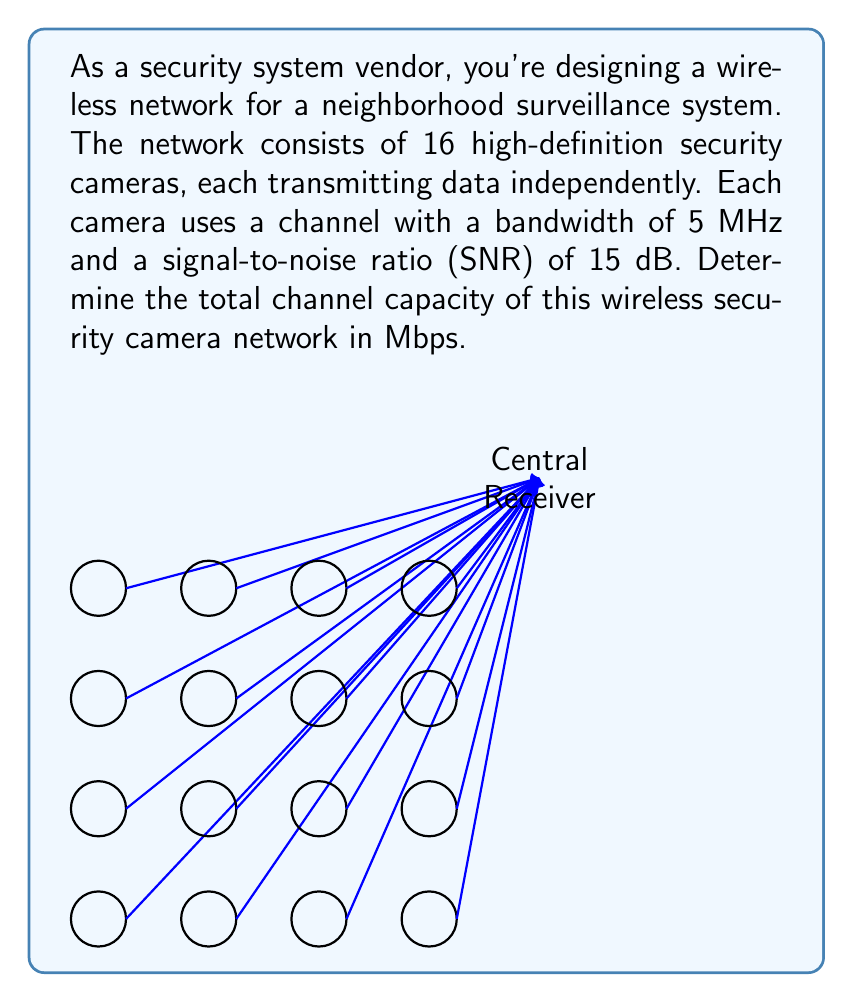Could you help me with this problem? Let's approach this step-by-step:

1) First, we need to calculate the channel capacity for a single camera using the Shannon-Hartley theorem:

   $C = B \log_2(1 + SNR)$

   Where:
   $C$ is the channel capacity in bits per second
   $B$ is the bandwidth in Hz
   $SNR$ is the Signal-to-Noise Ratio

2) We're given the bandwidth $B = 5$ MHz = $5 \times 10^6$ Hz

3) The SNR is given in dB, so we need to convert it to a linear scale:
   $SNR_{linear} = 10^{SNR_{dB}/10} = 10^{15/10} \approx 31.6228$

4) Now we can calculate the capacity for a single camera:

   $C = (5 \times 10^6) \log_2(1 + 31.6228)$
   $C = (5 \times 10^6) \log_2(32.6228)$
   $C = (5 \times 10^6) \times 5.0279$
   $C = 25.1395 \times 10^6$ bits per second
   $C \approx 25.1395$ Mbps

5) Since we have 16 cameras, and each operates independently, the total capacity is simply 16 times the capacity of a single camera:

   $C_{total} = 16 \times 25.1395 \approx 402.232$ Mbps

Therefore, the total channel capacity of the wireless security camera network is approximately 402.232 Mbps.
Answer: 402.232 Mbps 